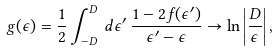<formula> <loc_0><loc_0><loc_500><loc_500>g ( \epsilon ) = \frac { 1 } { 2 } \int _ { - D } ^ { D } \, d \epsilon ^ { \prime } \, \frac { 1 - 2 f ( \epsilon ^ { \prime } ) } { \epsilon ^ { \prime } - \epsilon } \rightarrow \ln \left | \frac { D } { \epsilon } \right | ,</formula> 